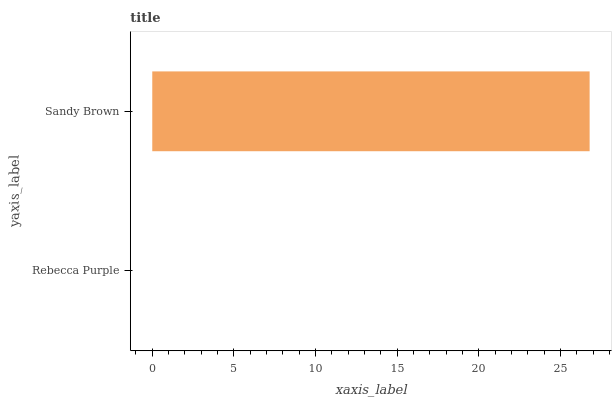Is Rebecca Purple the minimum?
Answer yes or no. Yes. Is Sandy Brown the maximum?
Answer yes or no. Yes. Is Sandy Brown the minimum?
Answer yes or no. No. Is Sandy Brown greater than Rebecca Purple?
Answer yes or no. Yes. Is Rebecca Purple less than Sandy Brown?
Answer yes or no. Yes. Is Rebecca Purple greater than Sandy Brown?
Answer yes or no. No. Is Sandy Brown less than Rebecca Purple?
Answer yes or no. No. Is Sandy Brown the high median?
Answer yes or no. Yes. Is Rebecca Purple the low median?
Answer yes or no. Yes. Is Rebecca Purple the high median?
Answer yes or no. No. Is Sandy Brown the low median?
Answer yes or no. No. 